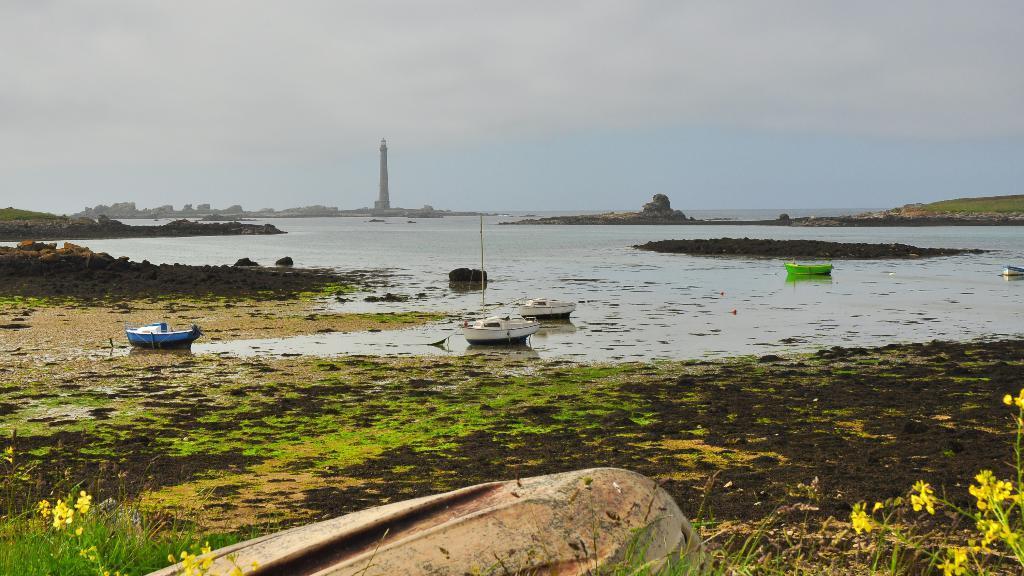Can you describe this image briefly? In this image in the front there are flowers. In the center there is water and on the water there are boats. In the background there is a tower and there are mountains and the sky is cloudy and in the center there are rocks. 